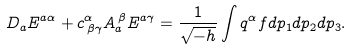Convert formula to latex. <formula><loc_0><loc_0><loc_500><loc_500>D _ { a } E ^ { a \alpha } + c ^ { \alpha } _ { \, \beta \gamma } A _ { a } ^ { \, \beta } E ^ { a \gamma } = \frac { 1 } { \sqrt { - h } } \int q ^ { \alpha } f d p _ { 1 } d p _ { 2 } d p _ { 3 } .</formula> 